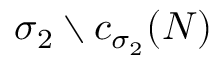Convert formula to latex. <formula><loc_0><loc_0><loc_500><loc_500>\sigma _ { 2 } \ c _ { \sigma _ { 2 } } ( { N } )</formula> 